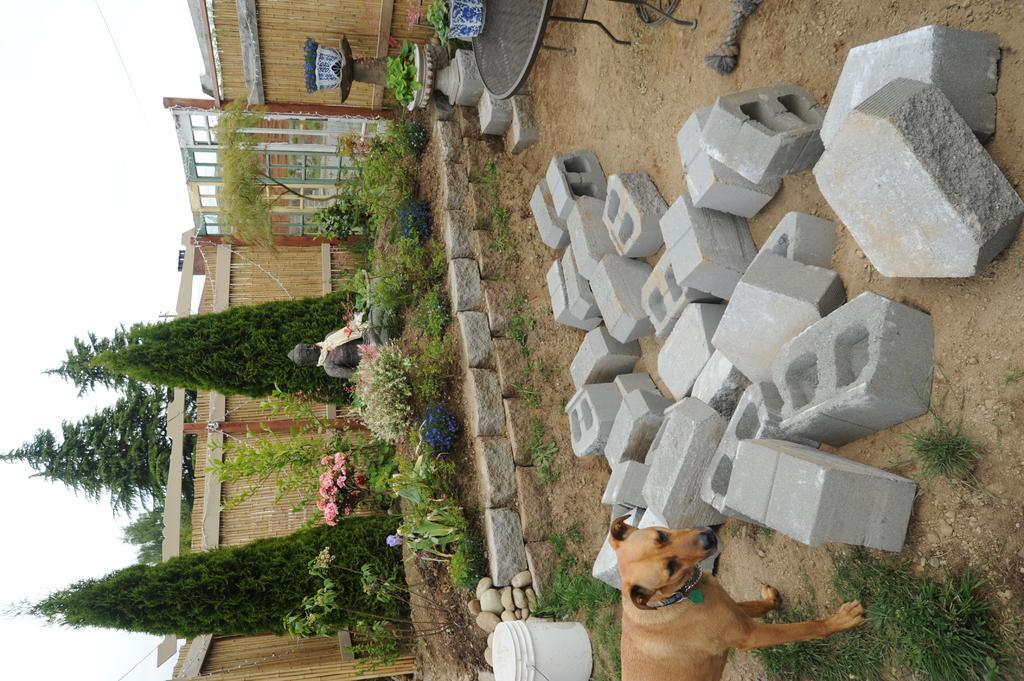Please provide a concise description of this image. In this picture we can see a dog, bucket, table, stones, plants and some objects on the ground, trees, flowers, statue, walls and in the background we can see the sky. 